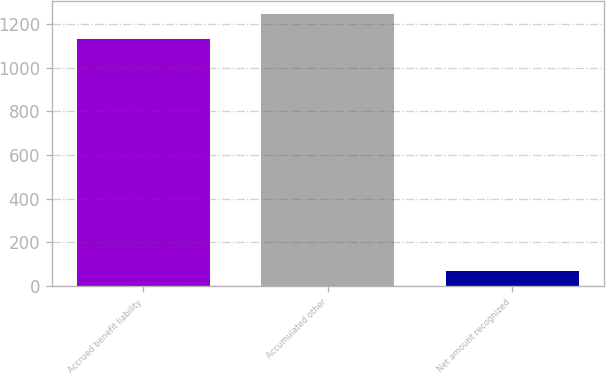<chart> <loc_0><loc_0><loc_500><loc_500><bar_chart><fcel>Accrued benefit liability<fcel>Accumulated other<fcel>Net amount recognized<nl><fcel>1132<fcel>1245.2<fcel>68<nl></chart> 